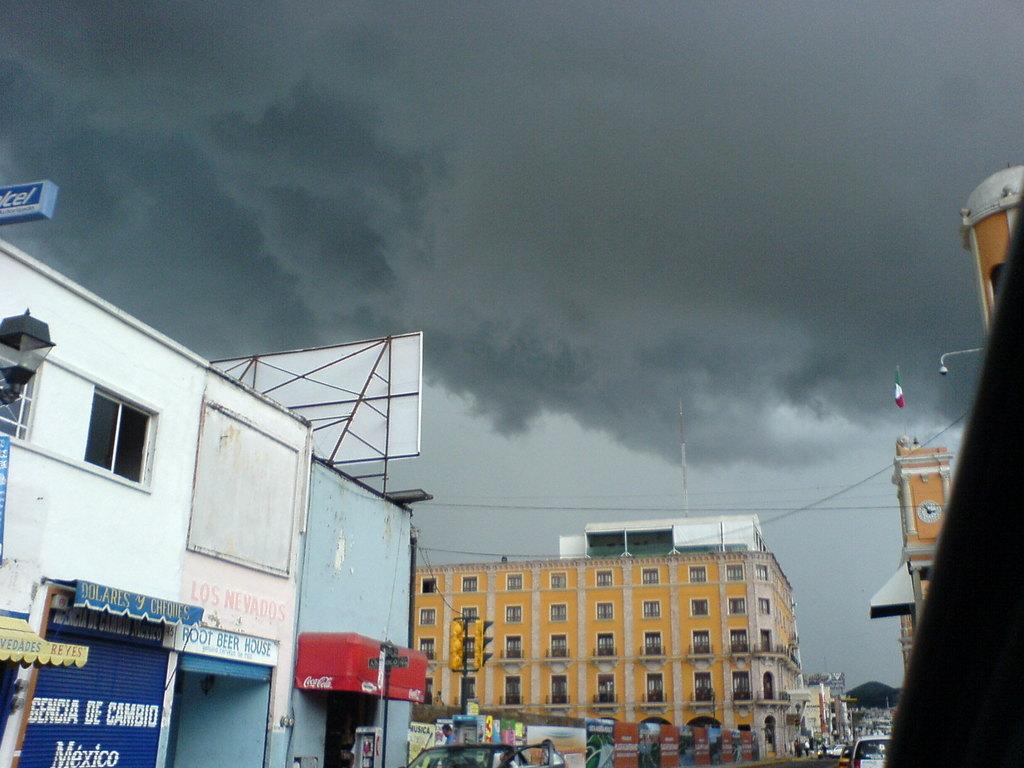What type of structures can be seen in the image? There are buildings in the image. Are there any signs or text visible on the buildings? Yes, there are wordings or text visible in the image. What type of establishments can be found in the image? There are shops in the image. Can you describe the flag in the image? There is a flag on one of the buildings. What is the condition of the sky in the image? The sky is visible at the top of the image and appears to be cloudy. Can you tell me how many seeds are scattered on the ground in the image? There are no seeds visible in the image; it features buildings, text, shops, a flag, and a cloudy sky. Are there any fairies flying around the buildings in the image? There are no fairies present in the image. 